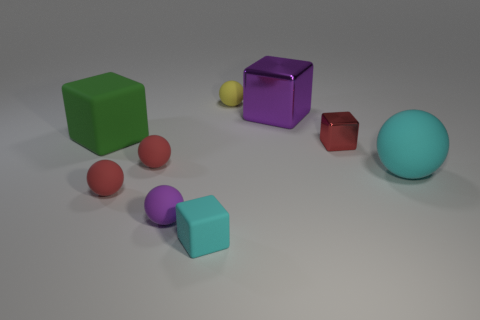There is a block that is the same color as the large rubber sphere; what is its material?
Your response must be concise. Rubber. There is another thing that is the same color as the large metallic thing; what is its shape?
Offer a terse response. Sphere. There is a thing that is the same color as the large sphere; what size is it?
Your response must be concise. Small. Do the large object left of the tiny yellow rubber ball and the big sphere have the same color?
Give a very brief answer. No. What number of things are either large matte things behind the big cyan matte ball or balls that are right of the tiny red shiny cube?
Keep it short and to the point. 2. What number of cubes are left of the large shiny thing and behind the tiny cyan rubber object?
Your answer should be compact. 1. Is the material of the small cyan block the same as the purple ball?
Your response must be concise. Yes. There is a red rubber thing that is in front of the small red matte sphere to the right of the small red matte ball in front of the big cyan rubber ball; what is its shape?
Provide a succinct answer. Sphere. There is a small sphere that is both behind the large rubber ball and left of the cyan block; what material is it made of?
Offer a very short reply. Rubber. The metal block in front of the metal block on the left side of the small thing that is right of the purple metal object is what color?
Make the answer very short. Red. 